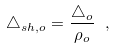<formula> <loc_0><loc_0><loc_500><loc_500>\triangle _ { s h , o } = \frac { \triangle _ { o } } { \rho _ { o } } \ ,</formula> 